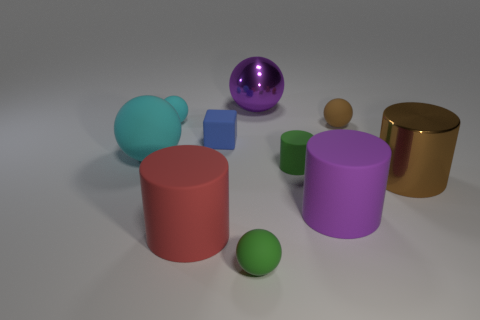There is a big ball right of the big cyan ball that is in front of the blue rubber block; what number of cylinders are on the right side of it?
Provide a succinct answer. 3. Do the matte cylinder behind the large brown thing and the big matte cylinder in front of the large purple cylinder have the same color?
Make the answer very short. No. What color is the rubber cylinder that is both to the right of the purple ball and to the left of the big purple matte cylinder?
Offer a very short reply. Green. What number of cyan things are the same size as the green rubber cylinder?
Keep it short and to the point. 1. There is a tiny green thing that is in front of the purple object that is right of the metal ball; what shape is it?
Ensure brevity in your answer.  Sphere. What is the shape of the tiny green thing that is in front of the green cylinder right of the big purple thing behind the big matte ball?
Your answer should be very brief. Sphere. How many big purple metallic things are the same shape as the tiny brown thing?
Make the answer very short. 1. How many small green things are left of the purple rubber cylinder behind the big red cylinder?
Offer a terse response. 2. What number of shiny objects are either large red things or blue cubes?
Offer a very short reply. 0. Are there any brown things made of the same material as the small cyan object?
Keep it short and to the point. Yes. 